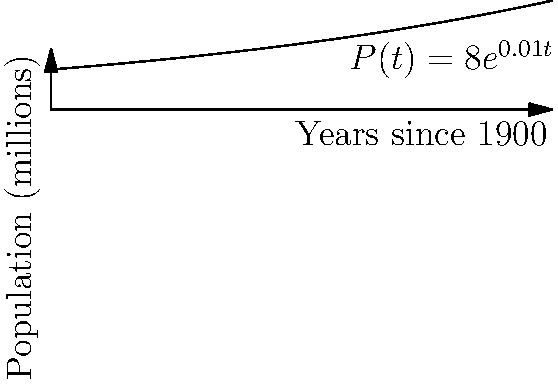Given the exponential function $P(t) = 8e^{0.01t}$ representing Portugal's population growth in millions during the 20th century, where $t$ is the number of years since 1900, calculate the instantaneous rate of population growth in 1950. To find the instantaneous rate of population growth in 1950, we need to follow these steps:

1) First, we need to find the derivative of the population function. The derivative represents the rate of change.
   $P(t) = 8e^{0.01t}$
   $P'(t) = 8 \cdot 0.01 \cdot e^{0.01t} = 0.08e^{0.01t}$

2) Now, we need to evaluate this derivative at t = 50 (since 1950 is 50 years after 1900).
   $P'(50) = 0.08e^{0.01 \cdot 50}$

3) Let's calculate this:
   $P'(50) = 0.08e^{0.5} \approx 0.1312$ million per year

4) To express this as a percentage of the population in 1950, we need to:
   a) Calculate the population in 1950: $P(50) = 8e^{0.01 \cdot 50} \approx 13.12$ million
   b) Divide the growth rate by the population and multiply by 100:
      $(0.1312 / 13.12) \cdot 100 = 1\%$

Therefore, the instantaneous rate of population growth in 1950 was approximately 1% per year.
Answer: 1% per year 